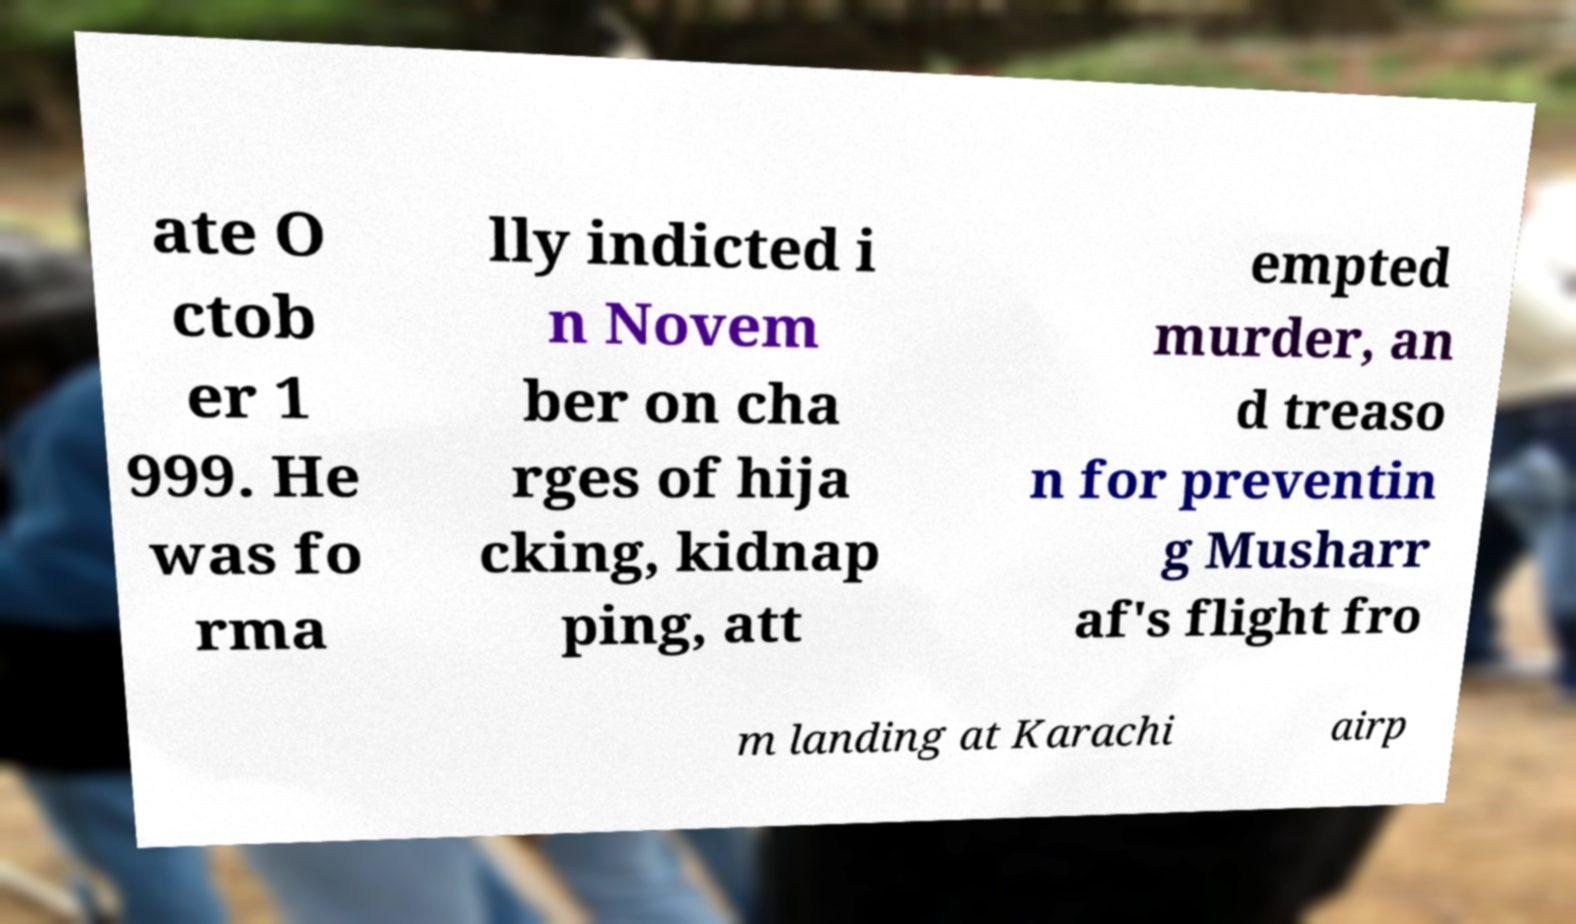What messages or text are displayed in this image? I need them in a readable, typed format. ate O ctob er 1 999. He was fo rma lly indicted i n Novem ber on cha rges of hija cking, kidnap ping, att empted murder, an d treaso n for preventin g Musharr af's flight fro m landing at Karachi airp 